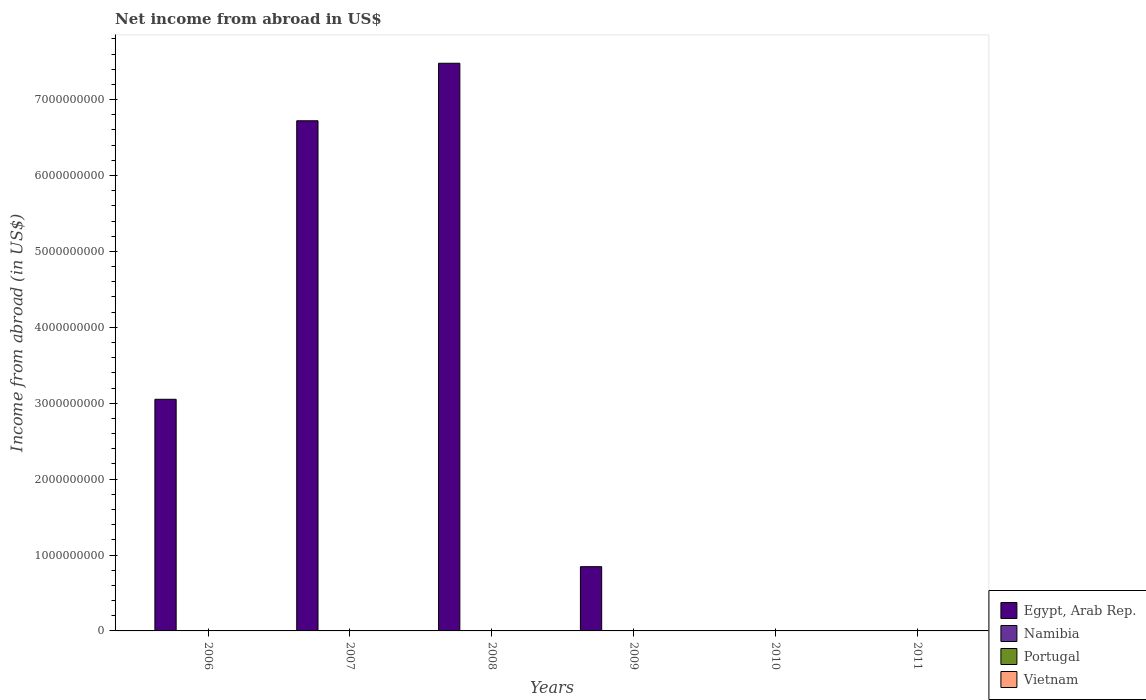How many bars are there on the 2nd tick from the left?
Make the answer very short. 1. What is the net income from abroad in Vietnam in 2010?
Provide a succinct answer. 0. Across all years, what is the maximum net income from abroad in Egypt, Arab Rep.?
Offer a very short reply. 7.48e+09. Across all years, what is the minimum net income from abroad in Egypt, Arab Rep.?
Your answer should be compact. 0. In which year was the net income from abroad in Egypt, Arab Rep. maximum?
Make the answer very short. 2008. What is the difference between the net income from abroad in Portugal in 2008 and the net income from abroad in Egypt, Arab Rep. in 2006?
Keep it short and to the point. -3.05e+09. What is the ratio of the net income from abroad in Egypt, Arab Rep. in 2006 to that in 2007?
Your response must be concise. 0.45. What is the difference between the highest and the second highest net income from abroad in Egypt, Arab Rep.?
Make the answer very short. 7.58e+08. What is the difference between the highest and the lowest net income from abroad in Egypt, Arab Rep.?
Give a very brief answer. 7.48e+09. In how many years, is the net income from abroad in Egypt, Arab Rep. greater than the average net income from abroad in Egypt, Arab Rep. taken over all years?
Offer a very short reply. 3. Is it the case that in every year, the sum of the net income from abroad in Namibia and net income from abroad in Egypt, Arab Rep. is greater than the sum of net income from abroad in Portugal and net income from abroad in Vietnam?
Keep it short and to the point. No. Is it the case that in every year, the sum of the net income from abroad in Vietnam and net income from abroad in Egypt, Arab Rep. is greater than the net income from abroad in Portugal?
Your answer should be compact. No. How many bars are there?
Give a very brief answer. 4. How many years are there in the graph?
Keep it short and to the point. 6. Does the graph contain any zero values?
Your answer should be compact. Yes. How many legend labels are there?
Give a very brief answer. 4. What is the title of the graph?
Provide a short and direct response. Net income from abroad in US$. What is the label or title of the X-axis?
Your answer should be compact. Years. What is the label or title of the Y-axis?
Your answer should be compact. Income from abroad (in US$). What is the Income from abroad (in US$) of Egypt, Arab Rep. in 2006?
Provide a short and direct response. 3.05e+09. What is the Income from abroad (in US$) in Namibia in 2006?
Your response must be concise. 0. What is the Income from abroad (in US$) in Vietnam in 2006?
Provide a succinct answer. 0. What is the Income from abroad (in US$) in Egypt, Arab Rep. in 2007?
Make the answer very short. 6.72e+09. What is the Income from abroad (in US$) in Namibia in 2007?
Your answer should be very brief. 0. What is the Income from abroad (in US$) of Vietnam in 2007?
Provide a short and direct response. 0. What is the Income from abroad (in US$) of Egypt, Arab Rep. in 2008?
Keep it short and to the point. 7.48e+09. What is the Income from abroad (in US$) in Namibia in 2008?
Provide a short and direct response. 0. What is the Income from abroad (in US$) in Egypt, Arab Rep. in 2009?
Keep it short and to the point. 8.46e+08. What is the Income from abroad (in US$) in Portugal in 2009?
Provide a succinct answer. 0. What is the Income from abroad (in US$) in Egypt, Arab Rep. in 2010?
Provide a short and direct response. 0. What is the Income from abroad (in US$) of Portugal in 2010?
Your answer should be very brief. 0. What is the Income from abroad (in US$) of Egypt, Arab Rep. in 2011?
Make the answer very short. 0. What is the Income from abroad (in US$) in Vietnam in 2011?
Your response must be concise. 0. Across all years, what is the maximum Income from abroad (in US$) of Egypt, Arab Rep.?
Give a very brief answer. 7.48e+09. Across all years, what is the minimum Income from abroad (in US$) of Egypt, Arab Rep.?
Make the answer very short. 0. What is the total Income from abroad (in US$) of Egypt, Arab Rep. in the graph?
Make the answer very short. 1.81e+1. What is the difference between the Income from abroad (in US$) in Egypt, Arab Rep. in 2006 and that in 2007?
Your answer should be very brief. -3.67e+09. What is the difference between the Income from abroad (in US$) in Egypt, Arab Rep. in 2006 and that in 2008?
Give a very brief answer. -4.43e+09. What is the difference between the Income from abroad (in US$) of Egypt, Arab Rep. in 2006 and that in 2009?
Your answer should be compact. 2.21e+09. What is the difference between the Income from abroad (in US$) of Egypt, Arab Rep. in 2007 and that in 2008?
Keep it short and to the point. -7.58e+08. What is the difference between the Income from abroad (in US$) of Egypt, Arab Rep. in 2007 and that in 2009?
Offer a terse response. 5.87e+09. What is the difference between the Income from abroad (in US$) in Egypt, Arab Rep. in 2008 and that in 2009?
Provide a short and direct response. 6.63e+09. What is the average Income from abroad (in US$) in Egypt, Arab Rep. per year?
Your response must be concise. 3.02e+09. What is the average Income from abroad (in US$) in Vietnam per year?
Provide a short and direct response. 0. What is the ratio of the Income from abroad (in US$) in Egypt, Arab Rep. in 2006 to that in 2007?
Make the answer very short. 0.45. What is the ratio of the Income from abroad (in US$) in Egypt, Arab Rep. in 2006 to that in 2008?
Offer a terse response. 0.41. What is the ratio of the Income from abroad (in US$) of Egypt, Arab Rep. in 2006 to that in 2009?
Give a very brief answer. 3.61. What is the ratio of the Income from abroad (in US$) of Egypt, Arab Rep. in 2007 to that in 2008?
Provide a succinct answer. 0.9. What is the ratio of the Income from abroad (in US$) in Egypt, Arab Rep. in 2007 to that in 2009?
Your answer should be compact. 7.94. What is the ratio of the Income from abroad (in US$) of Egypt, Arab Rep. in 2008 to that in 2009?
Offer a terse response. 8.84. What is the difference between the highest and the second highest Income from abroad (in US$) of Egypt, Arab Rep.?
Make the answer very short. 7.58e+08. What is the difference between the highest and the lowest Income from abroad (in US$) of Egypt, Arab Rep.?
Offer a terse response. 7.48e+09. 